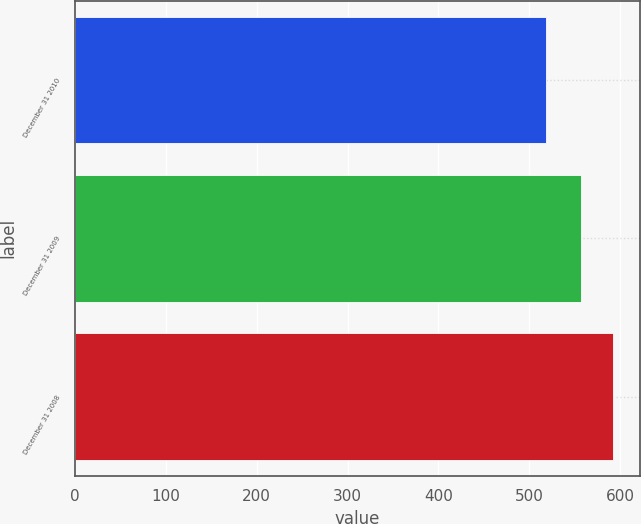Convert chart to OTSL. <chart><loc_0><loc_0><loc_500><loc_500><bar_chart><fcel>December 31 2010<fcel>December 31 2009<fcel>December 31 2008<nl><fcel>517.9<fcel>557.3<fcel>591.7<nl></chart> 